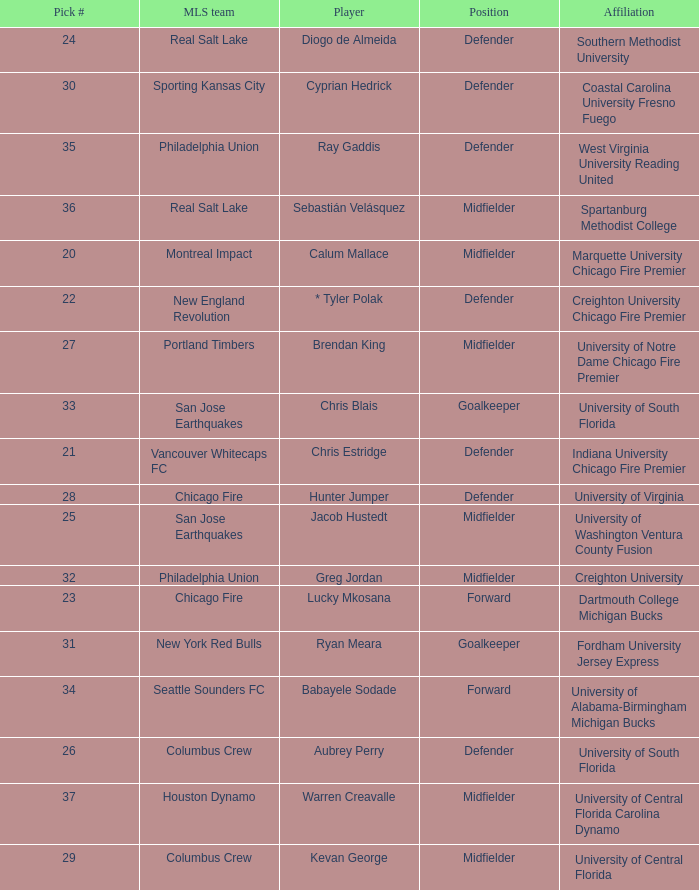What MLS team picked Babayele Sodade? Seattle Sounders FC. 